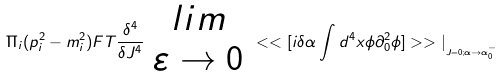Convert formula to latex. <formula><loc_0><loc_0><loc_500><loc_500>\Pi _ { i } ( p _ { i } ^ { 2 } - m _ { i } ^ { 2 } ) F T \frac { \delta ^ { 4 } } { \delta J ^ { 4 } } \begin{array} { c } { l i m } \\ { \varepsilon \rightarrow 0 } \end{array} < < [ i \delta \alpha \int d ^ { 4 } x \phi \partial _ { 0 } ^ { 2 } \phi ] > > | _ { _ { J = 0 ; \alpha \rightarrow \alpha _ { 0 } ^ { - } } }</formula> 